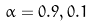Convert formula to latex. <formula><loc_0><loc_0><loc_500><loc_500>\alpha = 0 . 9 , 0 . 1</formula> 